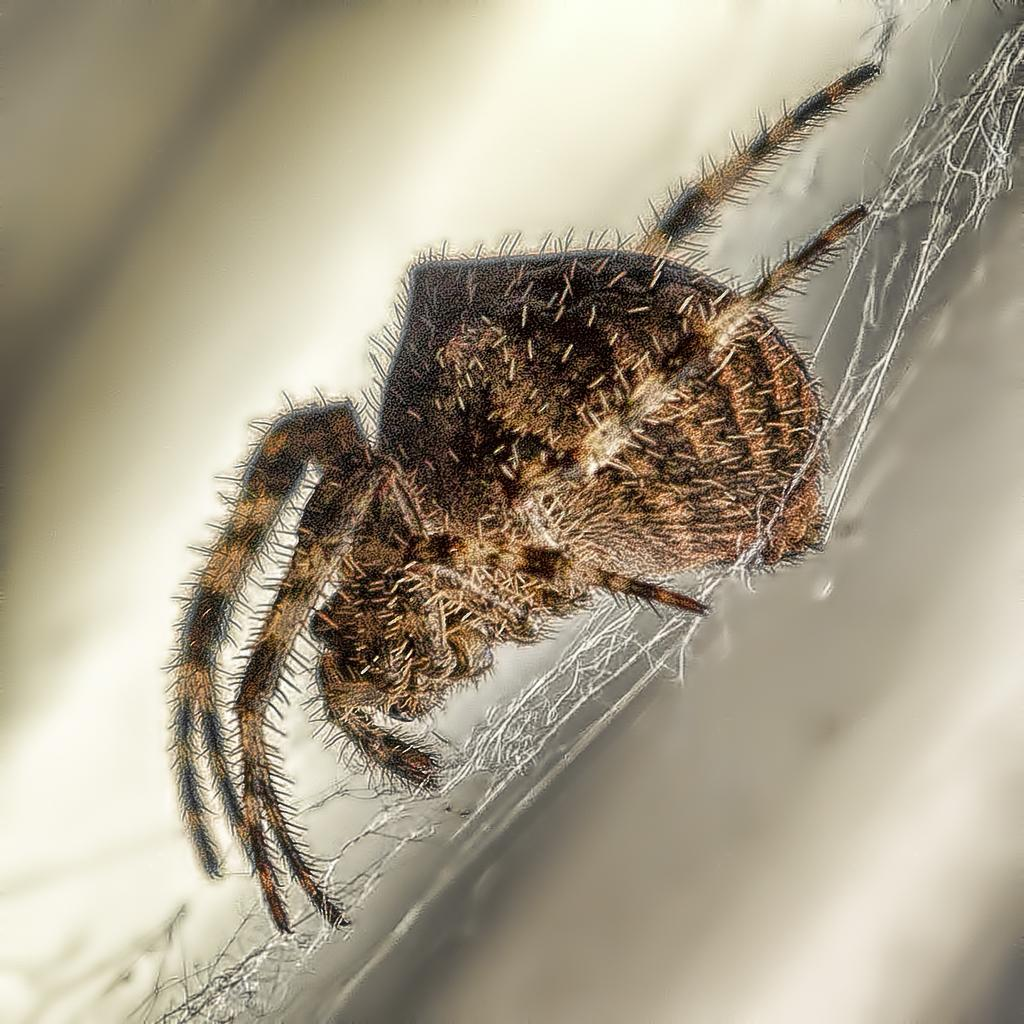What is the main subject of the image? The main subject of the image is a spider. Where is the spider located in the image? The spider is on a web. What type of hands can be seen holding the spider in the image? There are no hands present in the image; the spider is on a web. What kind of apparatus is used to spin the web in the image? There is no apparatus visible in the image; the spider is on a web. 